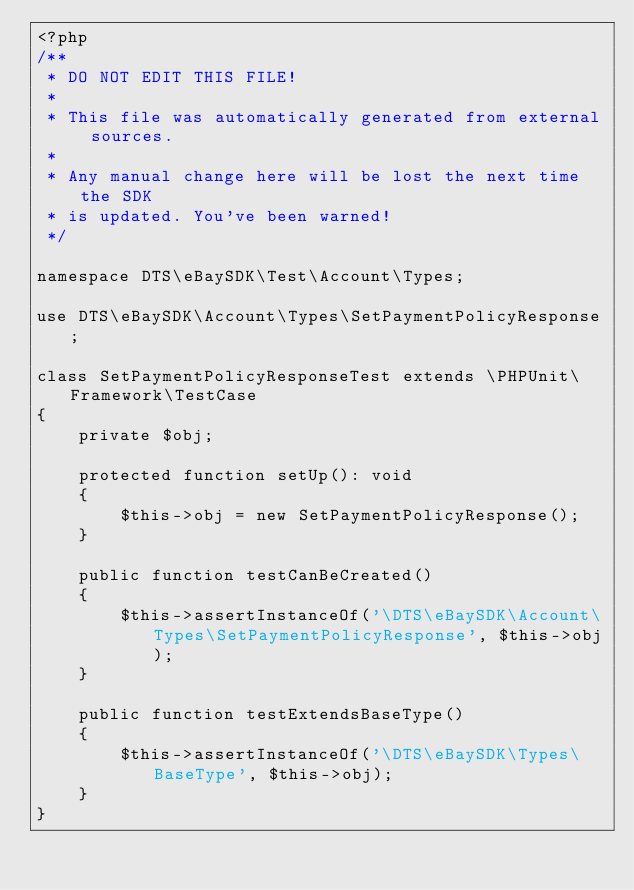<code> <loc_0><loc_0><loc_500><loc_500><_PHP_><?php
/**
 * DO NOT EDIT THIS FILE!
 *
 * This file was automatically generated from external sources.
 *
 * Any manual change here will be lost the next time the SDK
 * is updated. You've been warned!
 */

namespace DTS\eBaySDK\Test\Account\Types;

use DTS\eBaySDK\Account\Types\SetPaymentPolicyResponse;

class SetPaymentPolicyResponseTest extends \PHPUnit\Framework\TestCase
{
    private $obj;

    protected function setUp(): void
    {
        $this->obj = new SetPaymentPolicyResponse();
    }

    public function testCanBeCreated()
    {
        $this->assertInstanceOf('\DTS\eBaySDK\Account\Types\SetPaymentPolicyResponse', $this->obj);
    }

    public function testExtendsBaseType()
    {
        $this->assertInstanceOf('\DTS\eBaySDK\Types\BaseType', $this->obj);
    }
}
</code> 